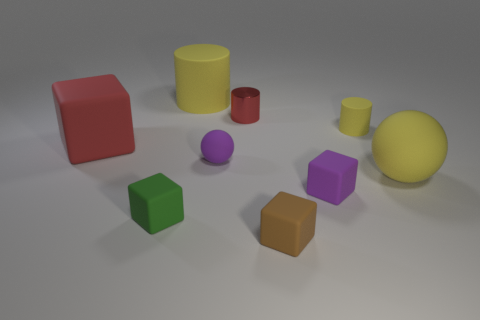What color is the small metallic object? There is no small metallic object visible in the image. The image shows a collection of geometric shapes, each of a different color, but none of them appears to be metallic in nature. 